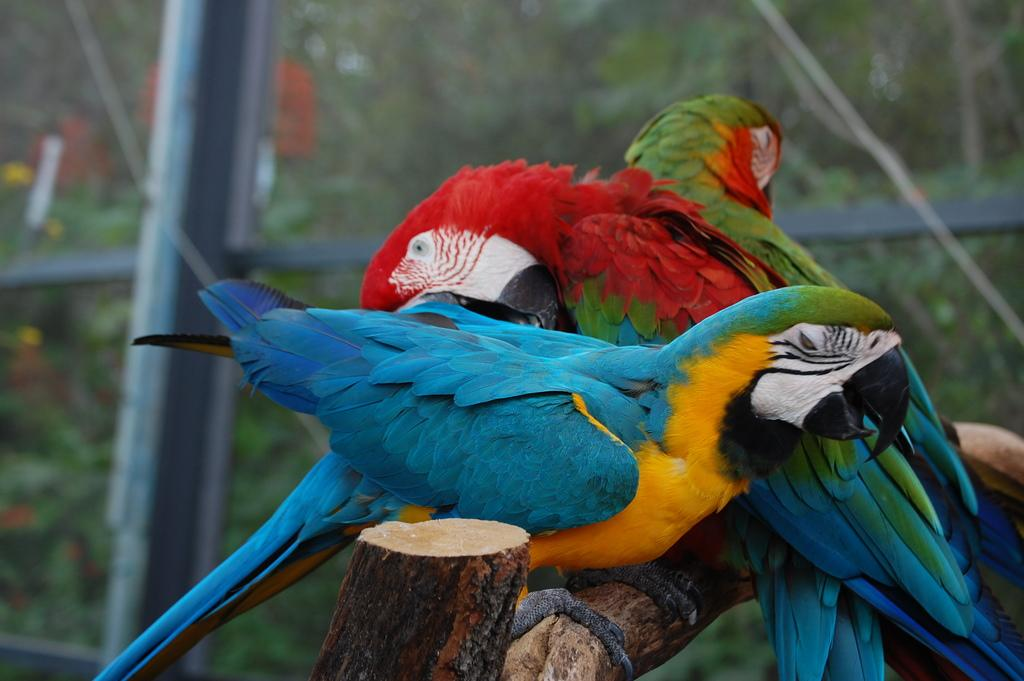How many parrots are in the image? There are three parrots in the image. Where are the parrots located? The parrots are on a branch. What can be observed about the appearance of the parrots? The parrots are in different colors. Can you describe the background of the image? The background of the image is blurred. What type of cheese is being used as a patch to fix the lamp in the image? There is no cheese or lamp present in the image; it features three parrots on a branch. 